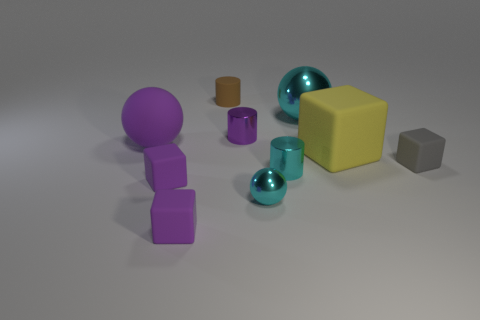There is a small rubber object that is behind the large matte sphere; what color is it?
Your response must be concise. Brown. There is a thing that is right of the big block; does it have the same shape as the cyan thing behind the purple cylinder?
Your response must be concise. No. Is there a brown cylinder that has the same size as the yellow rubber cube?
Your response must be concise. No. What is the small purple thing that is behind the large yellow object made of?
Offer a very short reply. Metal. Is the big sphere behind the small purple metal cylinder made of the same material as the small purple cylinder?
Offer a very short reply. Yes. Is there a large yellow thing?
Give a very brief answer. Yes. The tiny cylinder that is made of the same material as the purple ball is what color?
Provide a short and direct response. Brown. The metallic sphere behind the cube behind the tiny rubber cube right of the big cyan sphere is what color?
Your response must be concise. Cyan. Does the yellow matte thing have the same size as the ball to the left of the small brown thing?
Ensure brevity in your answer.  Yes. What number of things are either large rubber cubes that are in front of the big purple thing or balls to the left of the cyan cylinder?
Your response must be concise. 3. 